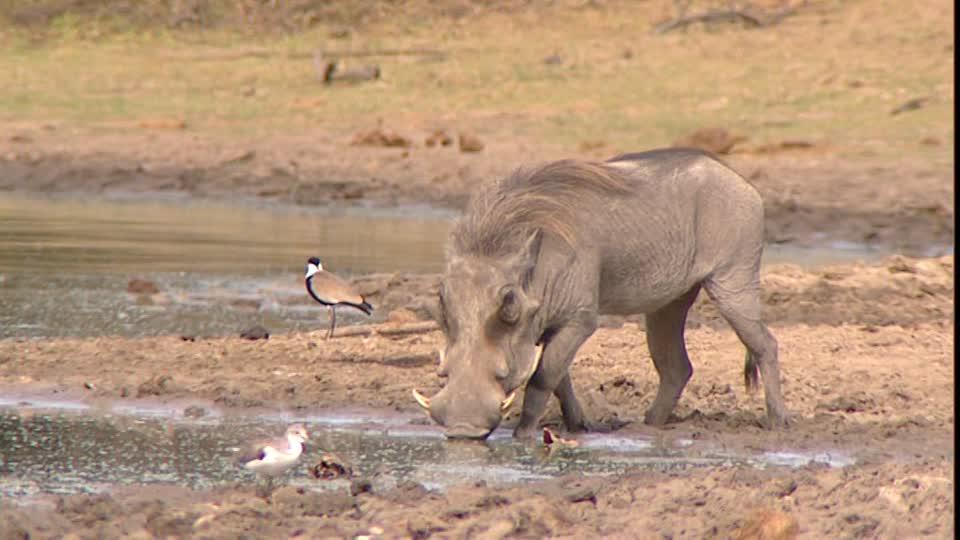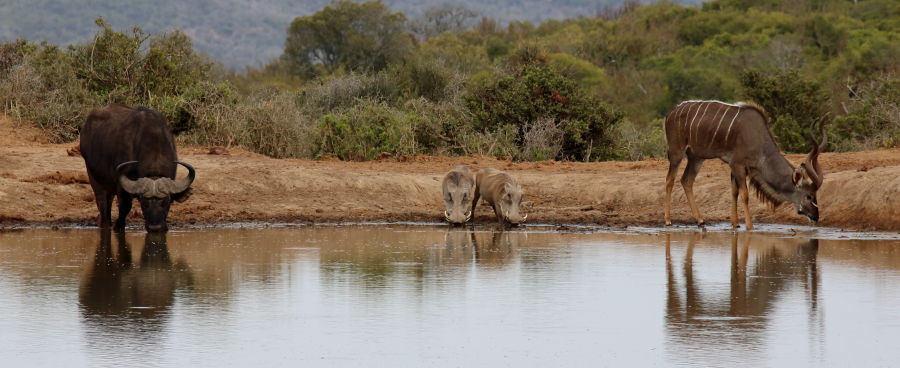The first image is the image on the left, the second image is the image on the right. Considering the images on both sides, is "Each image shows exactly one warthog, which is standing with its front knees on the ground." valid? Answer yes or no. No. The first image is the image on the left, the second image is the image on the right. For the images shown, is this caption "At least one animal in one of the images in near a watery area." true? Answer yes or no. Yes. 